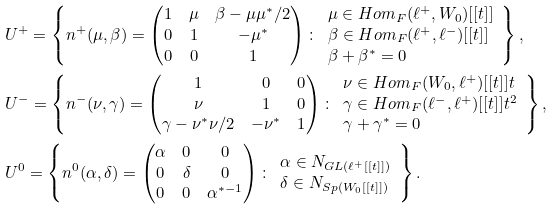Convert formula to latex. <formula><loc_0><loc_0><loc_500><loc_500>& U ^ { + } = \left \{ n ^ { + } ( \mu , \beta ) = \begin{pmatrix} 1 & \mu & \beta - \mu \mu ^ { * } / 2 \\ 0 & 1 & - \mu ^ { * } \\ 0 & 0 & 1 \end{pmatrix} \colon \begin{array} { l } \mu \in H o m _ { F } ( \ell ^ { + } , W _ { 0 } ) [ [ t ] ] \\ \beta \in H o m _ { F } ( \ell ^ { + } , \ell ^ { - } ) [ [ t ] ] \\ \beta + \beta ^ { * } = 0 \end{array} \right \} , \\ & U ^ { - } = \left \{ n ^ { - } ( \nu , \gamma ) = \begin{pmatrix} 1 & 0 & 0 \\ \nu & 1 & 0 \\ \gamma - \nu ^ { * } \nu / 2 & - \nu ^ { * } & 1 \end{pmatrix} \colon \begin{array} { l } \nu \in H o m _ { F } ( W _ { 0 } , \ell ^ { + } ) [ [ t ] ] t \\ \gamma \in H o m _ { F } ( \ell ^ { - } , \ell ^ { + } ) [ [ t ] ] t ^ { 2 } \\ \gamma + \gamma ^ { * } = 0 \end{array} \right \} , \\ & U ^ { 0 } = \left \{ n ^ { 0 } ( \alpha , \delta ) = \begin{pmatrix} \alpha & 0 & 0 \\ 0 & \delta & 0 \\ 0 & 0 & \alpha ^ { * - 1 } \end{pmatrix} \colon \begin{array} { l } \alpha \in N _ { G L ( \ell ^ { + } [ [ t ] ] ) } \\ \delta \in N _ { S p ( W _ { 0 } [ [ t ] ] ) } \end{array} \right \} .</formula> 